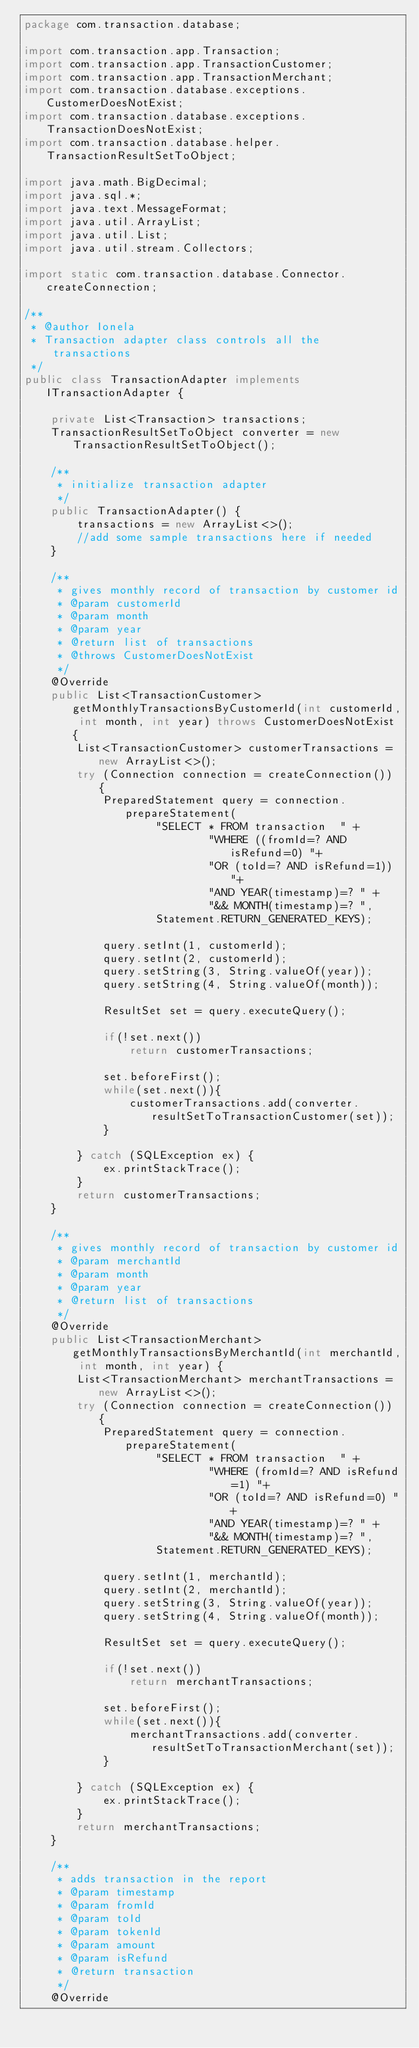Convert code to text. <code><loc_0><loc_0><loc_500><loc_500><_Java_>package com.transaction.database;

import com.transaction.app.Transaction;
import com.transaction.app.TransactionCustomer;
import com.transaction.app.TransactionMerchant;
import com.transaction.database.exceptions.CustomerDoesNotExist;
import com.transaction.database.exceptions.TransactionDoesNotExist;
import com.transaction.database.helper.TransactionResultSetToObject;

import java.math.BigDecimal;
import java.sql.*;
import java.text.MessageFormat;
import java.util.ArrayList;
import java.util.List;
import java.util.stream.Collectors;

import static com.transaction.database.Connector.createConnection;

/**
 * @author Ionela
 * Transaction adapter class controls all the transactions
 */
public class TransactionAdapter implements ITransactionAdapter {

    private List<Transaction> transactions;
    TransactionResultSetToObject converter = new TransactionResultSetToObject();

    /**
     * initialize transaction adapter
     */
    public TransactionAdapter() {
        transactions = new ArrayList<>();
        //add some sample transactions here if needed
    }

    /**
     * gives monthly record of transaction by customer id
     * @param customerId
     * @param month
     * @param year
     * @return list of transactions
     * @throws CustomerDoesNotExist
     */
    @Override
    public List<TransactionCustomer> getMonthlyTransactionsByCustomerId(int customerId, int month, int year) throws CustomerDoesNotExist {
        List<TransactionCustomer> customerTransactions = new ArrayList<>();
        try (Connection connection = createConnection()) {
            PreparedStatement query = connection.prepareStatement(
                    "SELECT * FROM transaction  " +
                            "WHERE ((fromId=? AND isRefund=0) "+
                            "OR (toId=? AND isRefund=1)) "+
                            "AND YEAR(timestamp)=? " +
                            "&& MONTH(timestamp)=? ",
                    Statement.RETURN_GENERATED_KEYS);

            query.setInt(1, customerId);
            query.setInt(2, customerId);
            query.setString(3, String.valueOf(year));
            query.setString(4, String.valueOf(month));

            ResultSet set = query.executeQuery();

            if(!set.next())
                return customerTransactions;

            set.beforeFirst();
            while(set.next()){
                customerTransactions.add(converter.resultSetToTransactionCustomer(set));
            }

        } catch (SQLException ex) {
            ex.printStackTrace();
        }
        return customerTransactions;
    }

    /**
     * gives monthly record of transaction by customer id
     * @param merchantId
     * @param month
     * @param year
     * @return list of transactions
     */
    @Override
    public List<TransactionMerchant> getMonthlyTransactionsByMerchantId(int merchantId, int month, int year) {
        List<TransactionMerchant> merchantTransactions = new ArrayList<>();
        try (Connection connection = createConnection()) {
            PreparedStatement query = connection.prepareStatement(
                    "SELECT * FROM transaction  " +
                            "WHERE (fromId=? AND isRefund=1) "+
                            "OR (toId=? AND isRefund=0) "+
                            "AND YEAR(timestamp)=? " +
                            "&& MONTH(timestamp)=? ",
                    Statement.RETURN_GENERATED_KEYS);

            query.setInt(1, merchantId);
            query.setInt(2, merchantId);
            query.setString(3, String.valueOf(year));
            query.setString(4, String.valueOf(month));

            ResultSet set = query.executeQuery();

            if(!set.next())
                return merchantTransactions;

            set.beforeFirst();
            while(set.next()){
                merchantTransactions.add(converter.resultSetToTransactionMerchant(set));
            }

        } catch (SQLException ex) {
            ex.printStackTrace();
        }
        return merchantTransactions;
    }

    /**
     * adds transaction in the report
     * @param timestamp
     * @param fromId
     * @param toId
     * @param tokenId
     * @param amount
     * @param isRefund
     * @return transaction
     */
    @Override</code> 